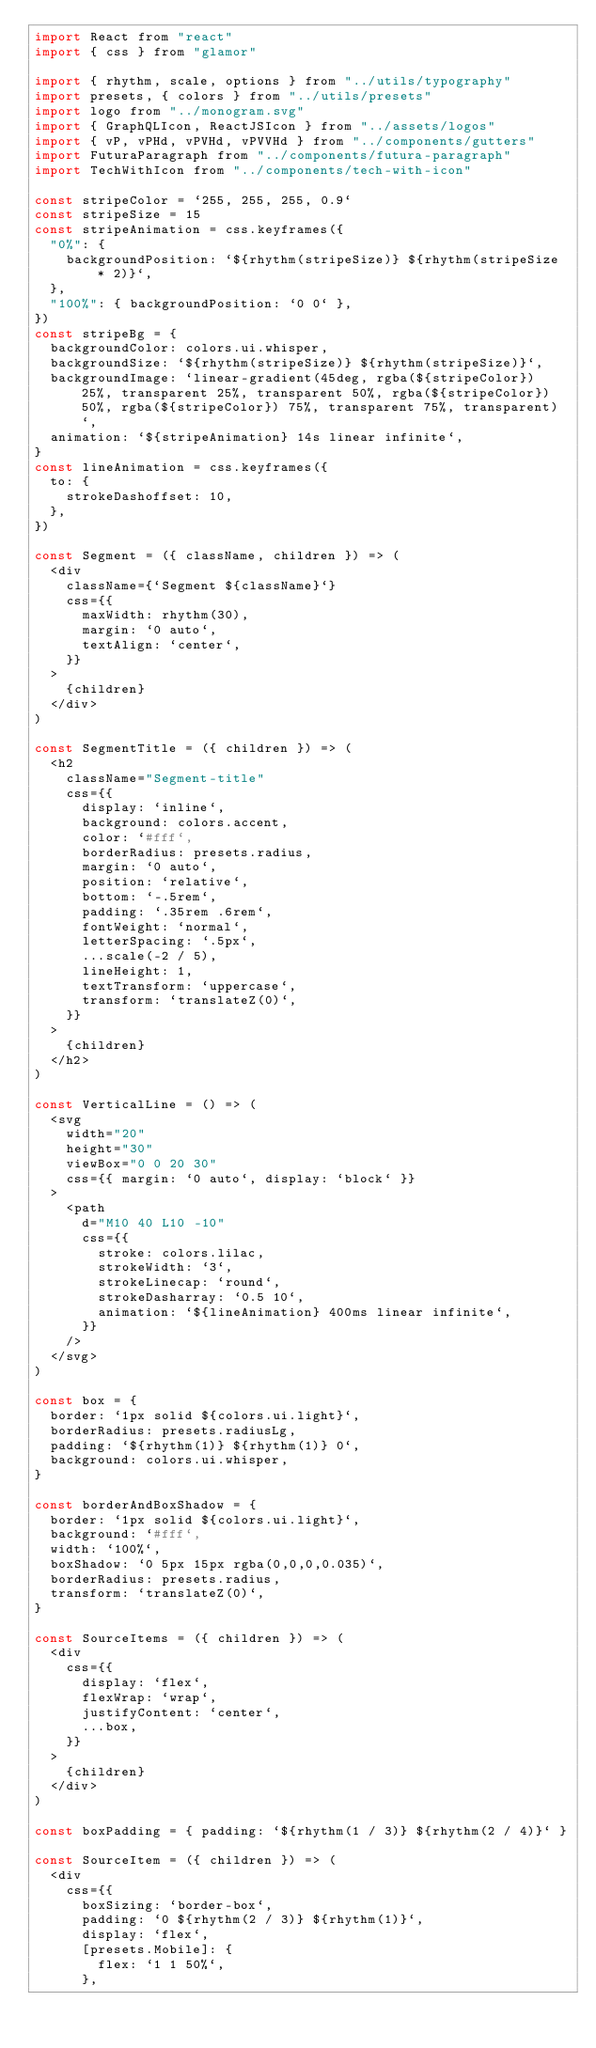<code> <loc_0><loc_0><loc_500><loc_500><_JavaScript_>import React from "react"
import { css } from "glamor"

import { rhythm, scale, options } from "../utils/typography"
import presets, { colors } from "../utils/presets"
import logo from "../monogram.svg"
import { GraphQLIcon, ReactJSIcon } from "../assets/logos"
import { vP, vPHd, vPVHd, vPVVHd } from "../components/gutters"
import FuturaParagraph from "../components/futura-paragraph"
import TechWithIcon from "../components/tech-with-icon"

const stripeColor = `255, 255, 255, 0.9`
const stripeSize = 15
const stripeAnimation = css.keyframes({
  "0%": {
    backgroundPosition: `${rhythm(stripeSize)} ${rhythm(stripeSize * 2)}`,
  },
  "100%": { backgroundPosition: `0 0` },
})
const stripeBg = {
  backgroundColor: colors.ui.whisper,
  backgroundSize: `${rhythm(stripeSize)} ${rhythm(stripeSize)}`,
  backgroundImage: `linear-gradient(45deg, rgba(${stripeColor}) 25%, transparent 25%, transparent 50%, rgba(${stripeColor}) 50%, rgba(${stripeColor}) 75%, transparent 75%, transparent)`,
  animation: `${stripeAnimation} 14s linear infinite`,
}
const lineAnimation = css.keyframes({
  to: {
    strokeDashoffset: 10,
  },
})

const Segment = ({ className, children }) => (
  <div
    className={`Segment ${className}`}
    css={{
      maxWidth: rhythm(30),
      margin: `0 auto`,
      textAlign: `center`,
    }}
  >
    {children}
  </div>
)

const SegmentTitle = ({ children }) => (
  <h2
    className="Segment-title"
    css={{
      display: `inline`,
      background: colors.accent,
      color: `#fff`,
      borderRadius: presets.radius,
      margin: `0 auto`,
      position: `relative`,
      bottom: `-.5rem`,
      padding: `.35rem .6rem`,
      fontWeight: `normal`,
      letterSpacing: `.5px`,
      ...scale(-2 / 5),
      lineHeight: 1,
      textTransform: `uppercase`,
      transform: `translateZ(0)`,
    }}
  >
    {children}
  </h2>
)

const VerticalLine = () => (
  <svg
    width="20"
    height="30"
    viewBox="0 0 20 30"
    css={{ margin: `0 auto`, display: `block` }}
  >
    <path
      d="M10 40 L10 -10"
      css={{
        stroke: colors.lilac,
        strokeWidth: `3`,
        strokeLinecap: `round`,
        strokeDasharray: `0.5 10`,
        animation: `${lineAnimation} 400ms linear infinite`,
      }}
    />
  </svg>
)

const box = {
  border: `1px solid ${colors.ui.light}`,
  borderRadius: presets.radiusLg,
  padding: `${rhythm(1)} ${rhythm(1)} 0`,
  background: colors.ui.whisper,
}

const borderAndBoxShadow = {
  border: `1px solid ${colors.ui.light}`,
  background: `#fff`,
  width: `100%`,
  boxShadow: `0 5px 15px rgba(0,0,0,0.035)`,
  borderRadius: presets.radius,
  transform: `translateZ(0)`,
}

const SourceItems = ({ children }) => (
  <div
    css={{
      display: `flex`,
      flexWrap: `wrap`,
      justifyContent: `center`,
      ...box,
    }}
  >
    {children}
  </div>
)

const boxPadding = { padding: `${rhythm(1 / 3)} ${rhythm(2 / 4)}` }

const SourceItem = ({ children }) => (
  <div
    css={{
      boxSizing: `border-box`,
      padding: `0 ${rhythm(2 / 3)} ${rhythm(1)}`,
      display: `flex`,
      [presets.Mobile]: {
        flex: `1 1 50%`,
      },</code> 